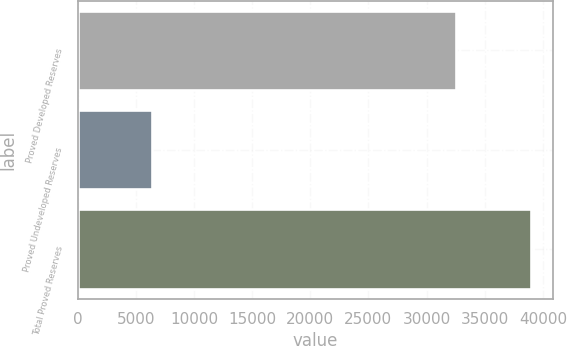Convert chart. <chart><loc_0><loc_0><loc_500><loc_500><bar_chart><fcel>Proved Developed Reserves<fcel>Proved Undeveloped Reserves<fcel>Total Proved Reserves<nl><fcel>32560<fcel>6379<fcel>38939<nl></chart> 